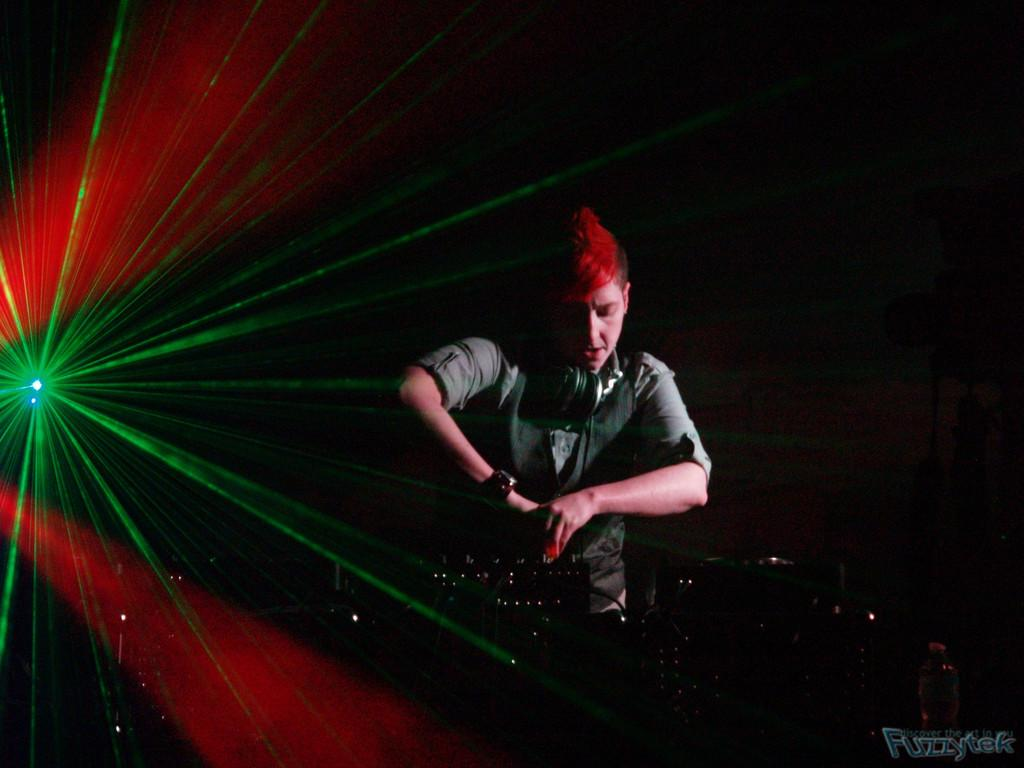Who or what is in the front of the image? There is a person in the front of the image. What can be seen on the left side of the image? There is a light on the left side of the image. How would you describe the background of the image? The background of the image is dark. Where is the text located in the image? The text is at the right bottom of the image. What is the distance between the person and the light in the image? The provided facts do not give any information about the distance between the person and the light, so it cannot be determined from the image. 